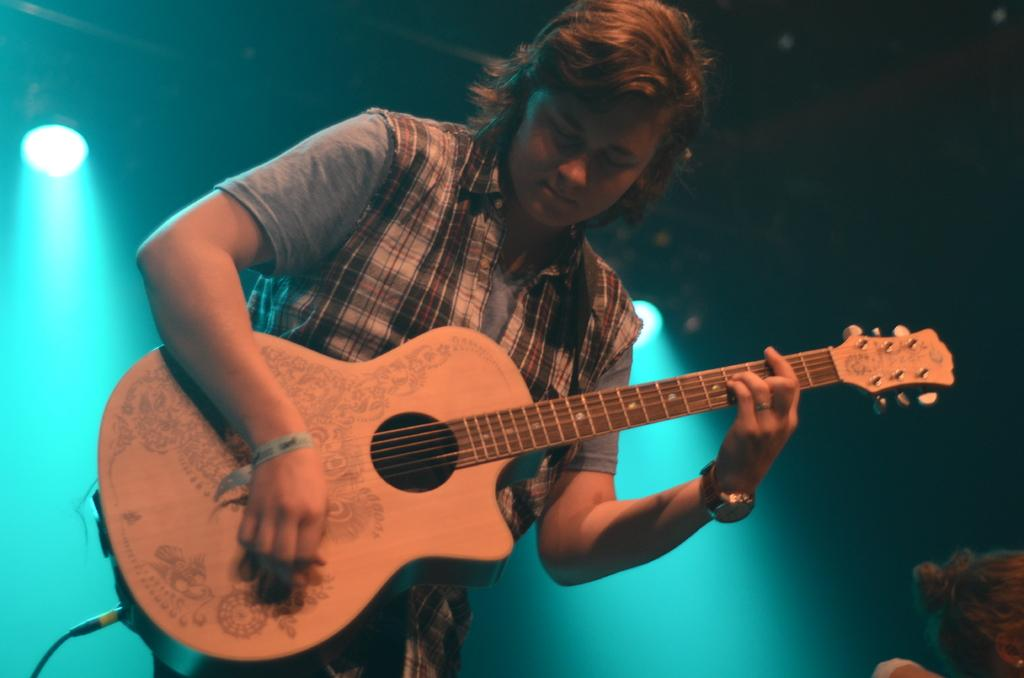What is the man in the image doing? The man is playing a guitar in the image. Can you describe the background of the image? There are lights visible in the background of the image. What type of wave can be seen crashing on the shore in the image? There is no wave or shore present in the image; it features a man playing a guitar with lights in the background. 